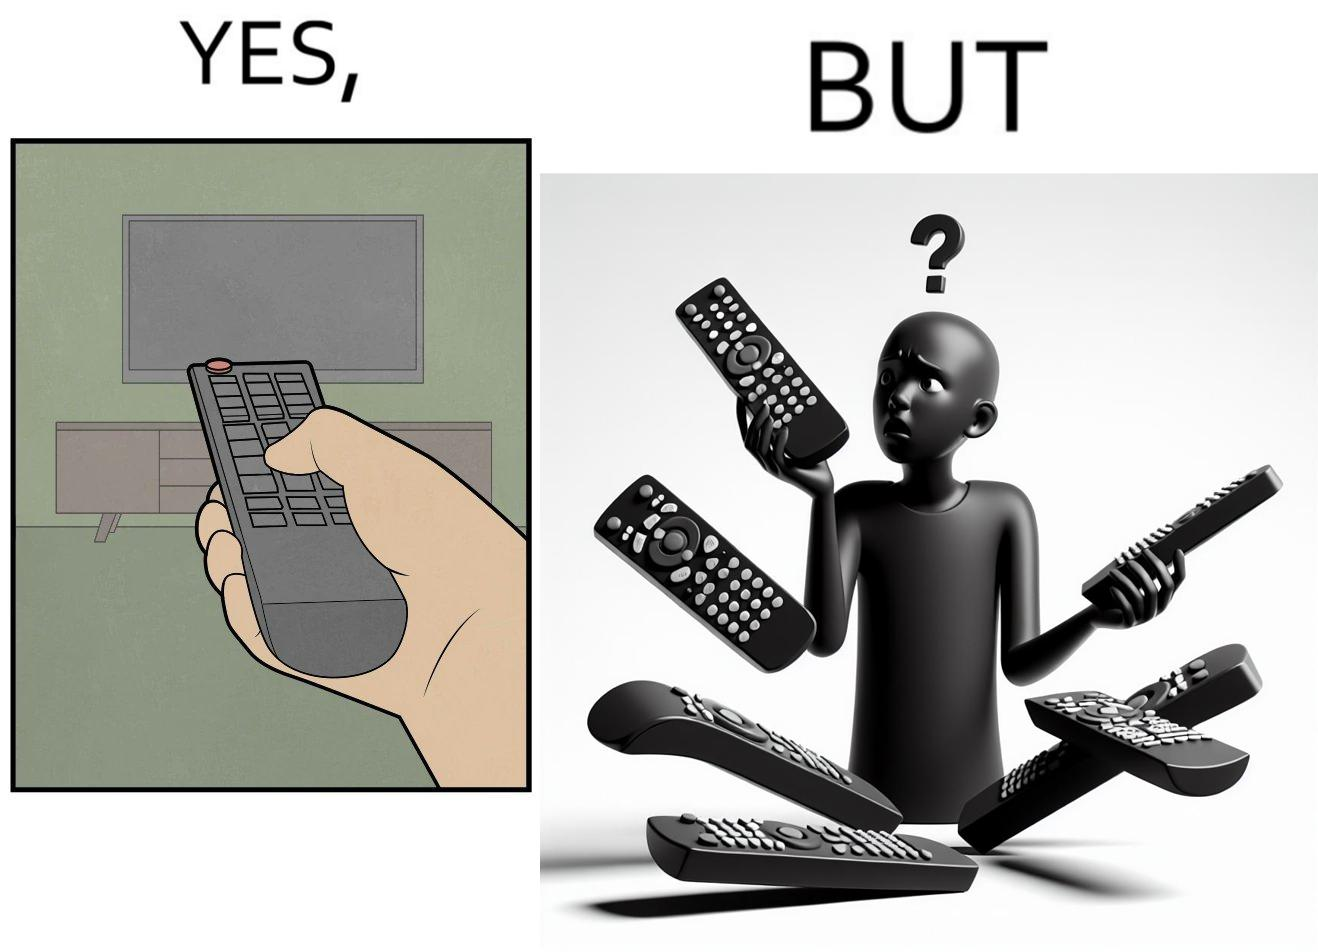Explain why this image is satirical. The images are funny since they show how even though TV remotes are supposed to make operating TVs easier, having multiple similar looking remotes  for everything only makes it more difficult for the user to use the right one 